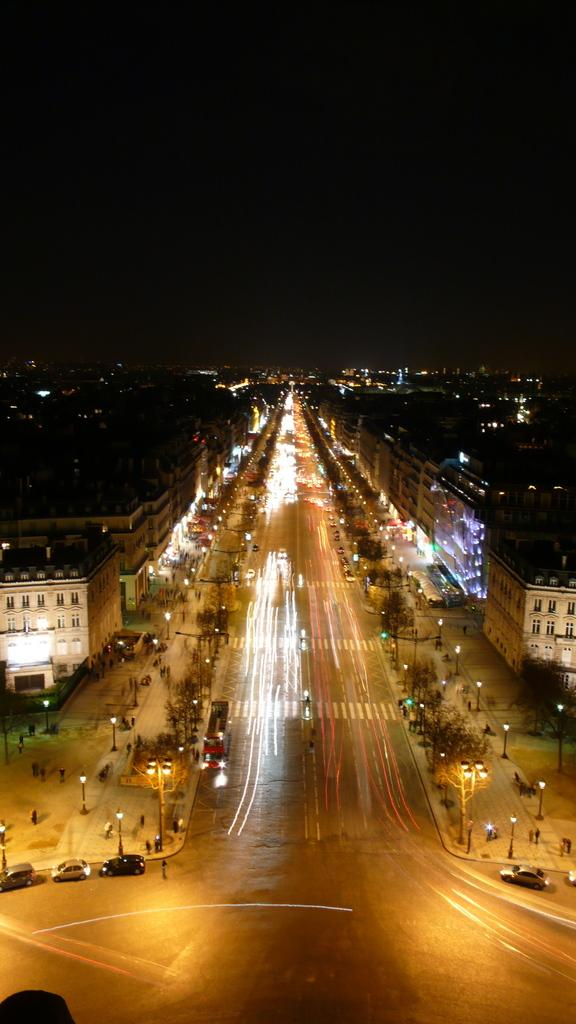What type of structures can be seen in the image? There are buildings in the image. What else is visible on the ground in the image? There are vehicles on the road in the image. Are there any lighting features in the image? Yes, there are street lights in the image. What time of day was the image captured? The image was captured at night. What type of company is represented by the logo on the scarf in the image? There is no scarf or logo present in the image. How does the map in the image help navigate the area? There is no map present in the image. 